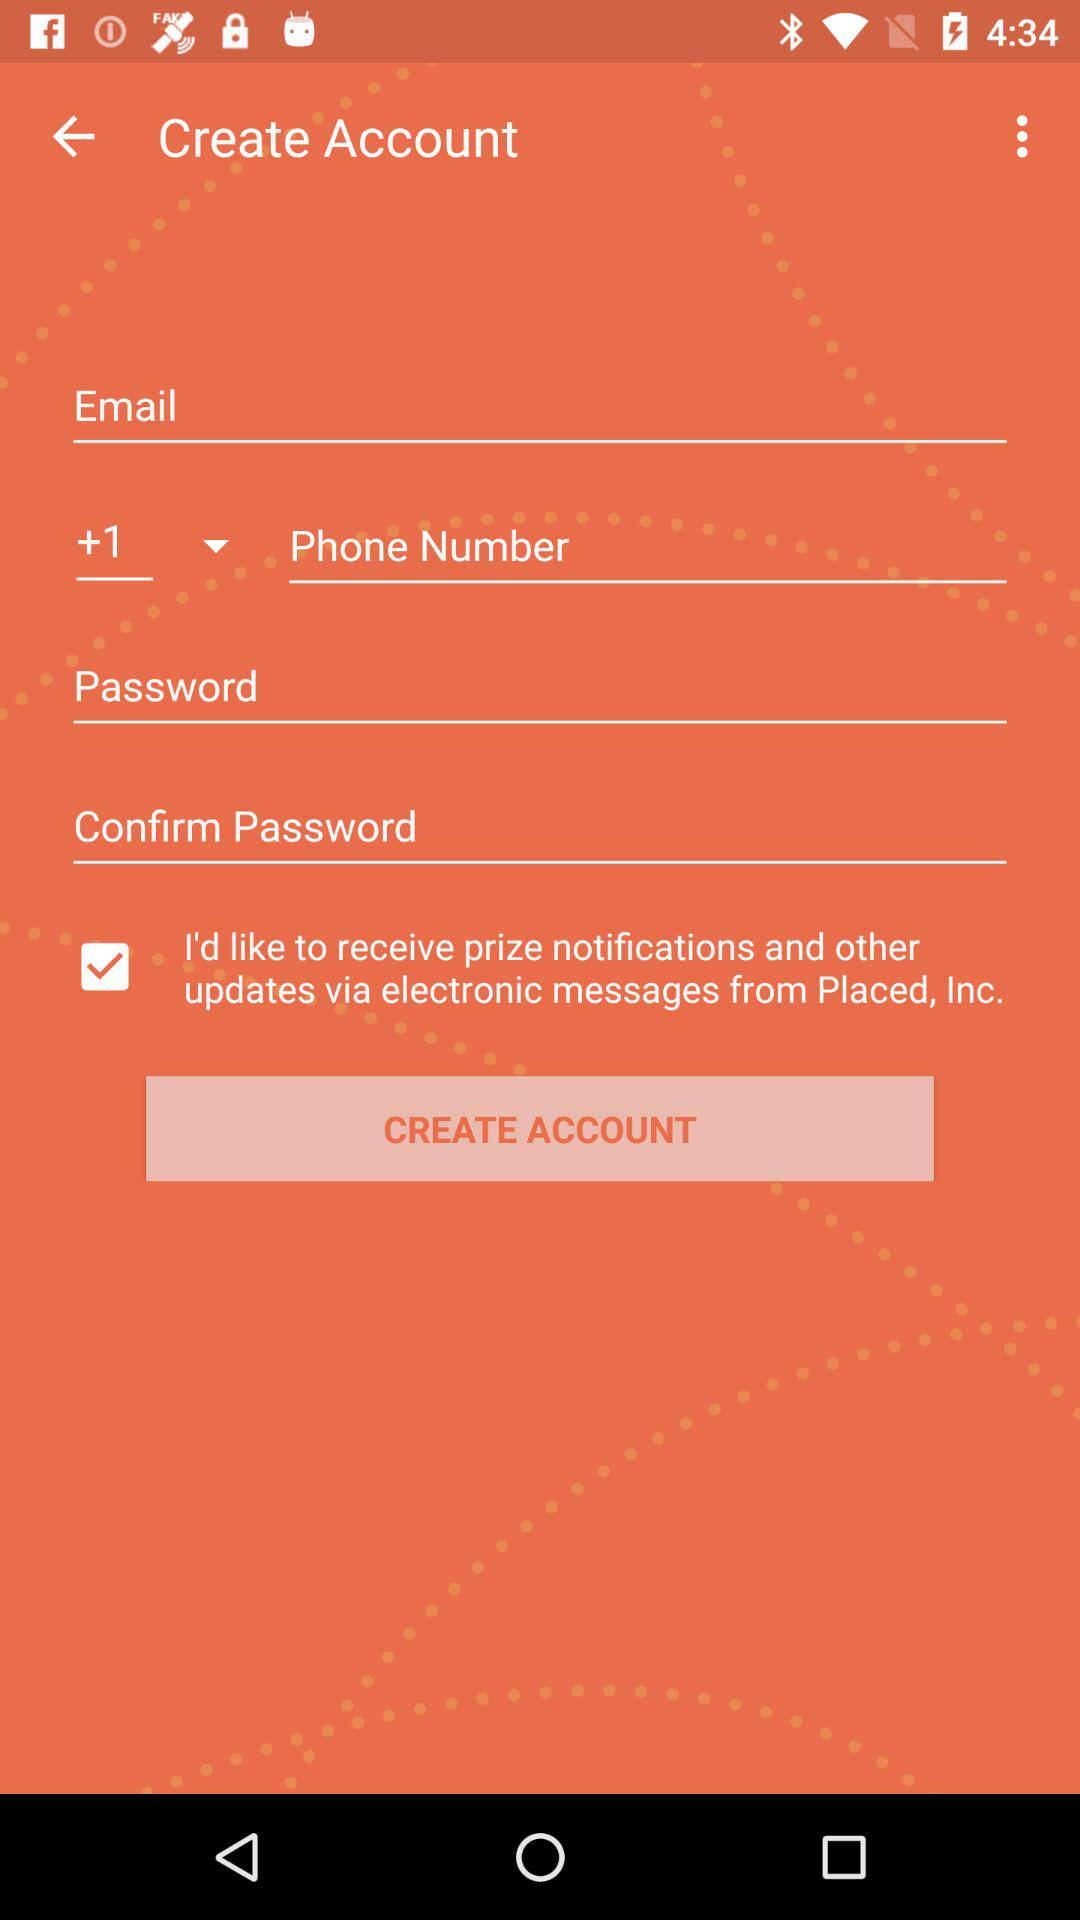What is the selected country code? The selected country code is +1. 